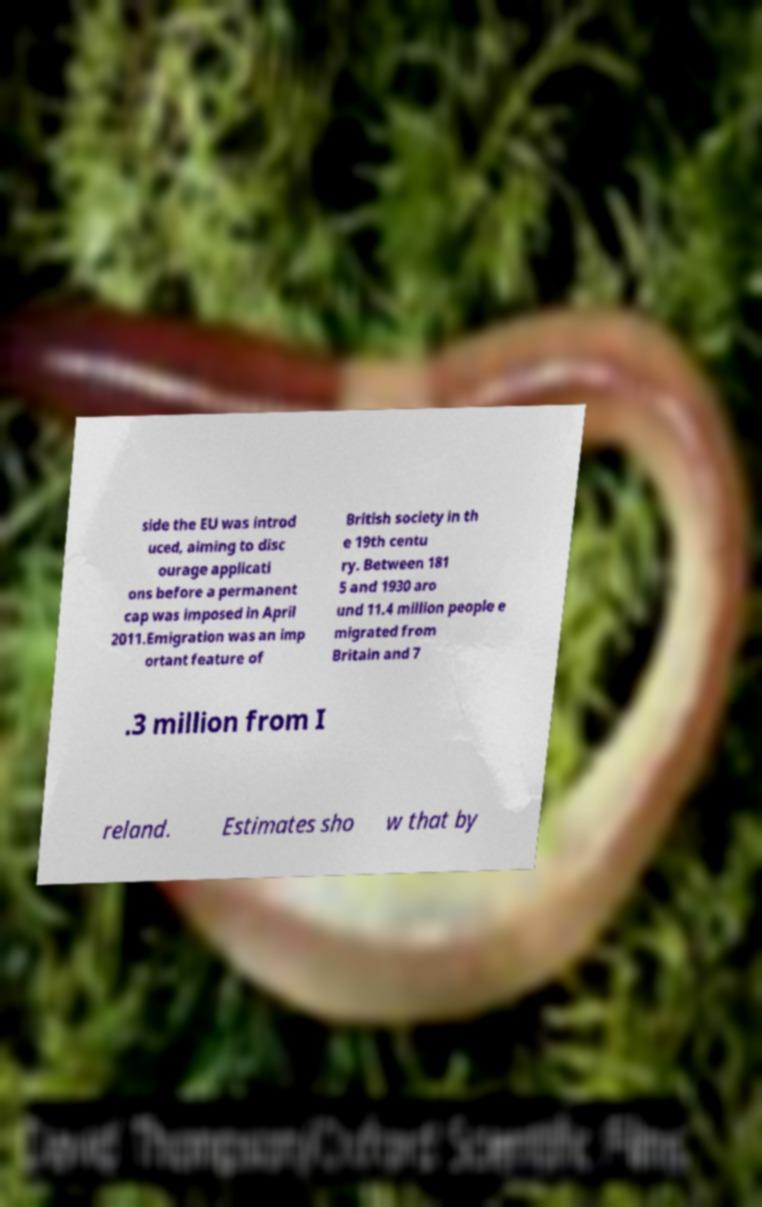Can you read and provide the text displayed in the image?This photo seems to have some interesting text. Can you extract and type it out for me? side the EU was introd uced, aiming to disc ourage applicati ons before a permanent cap was imposed in April 2011.Emigration was an imp ortant feature of British society in th e 19th centu ry. Between 181 5 and 1930 aro und 11.4 million people e migrated from Britain and 7 .3 million from I reland. Estimates sho w that by 